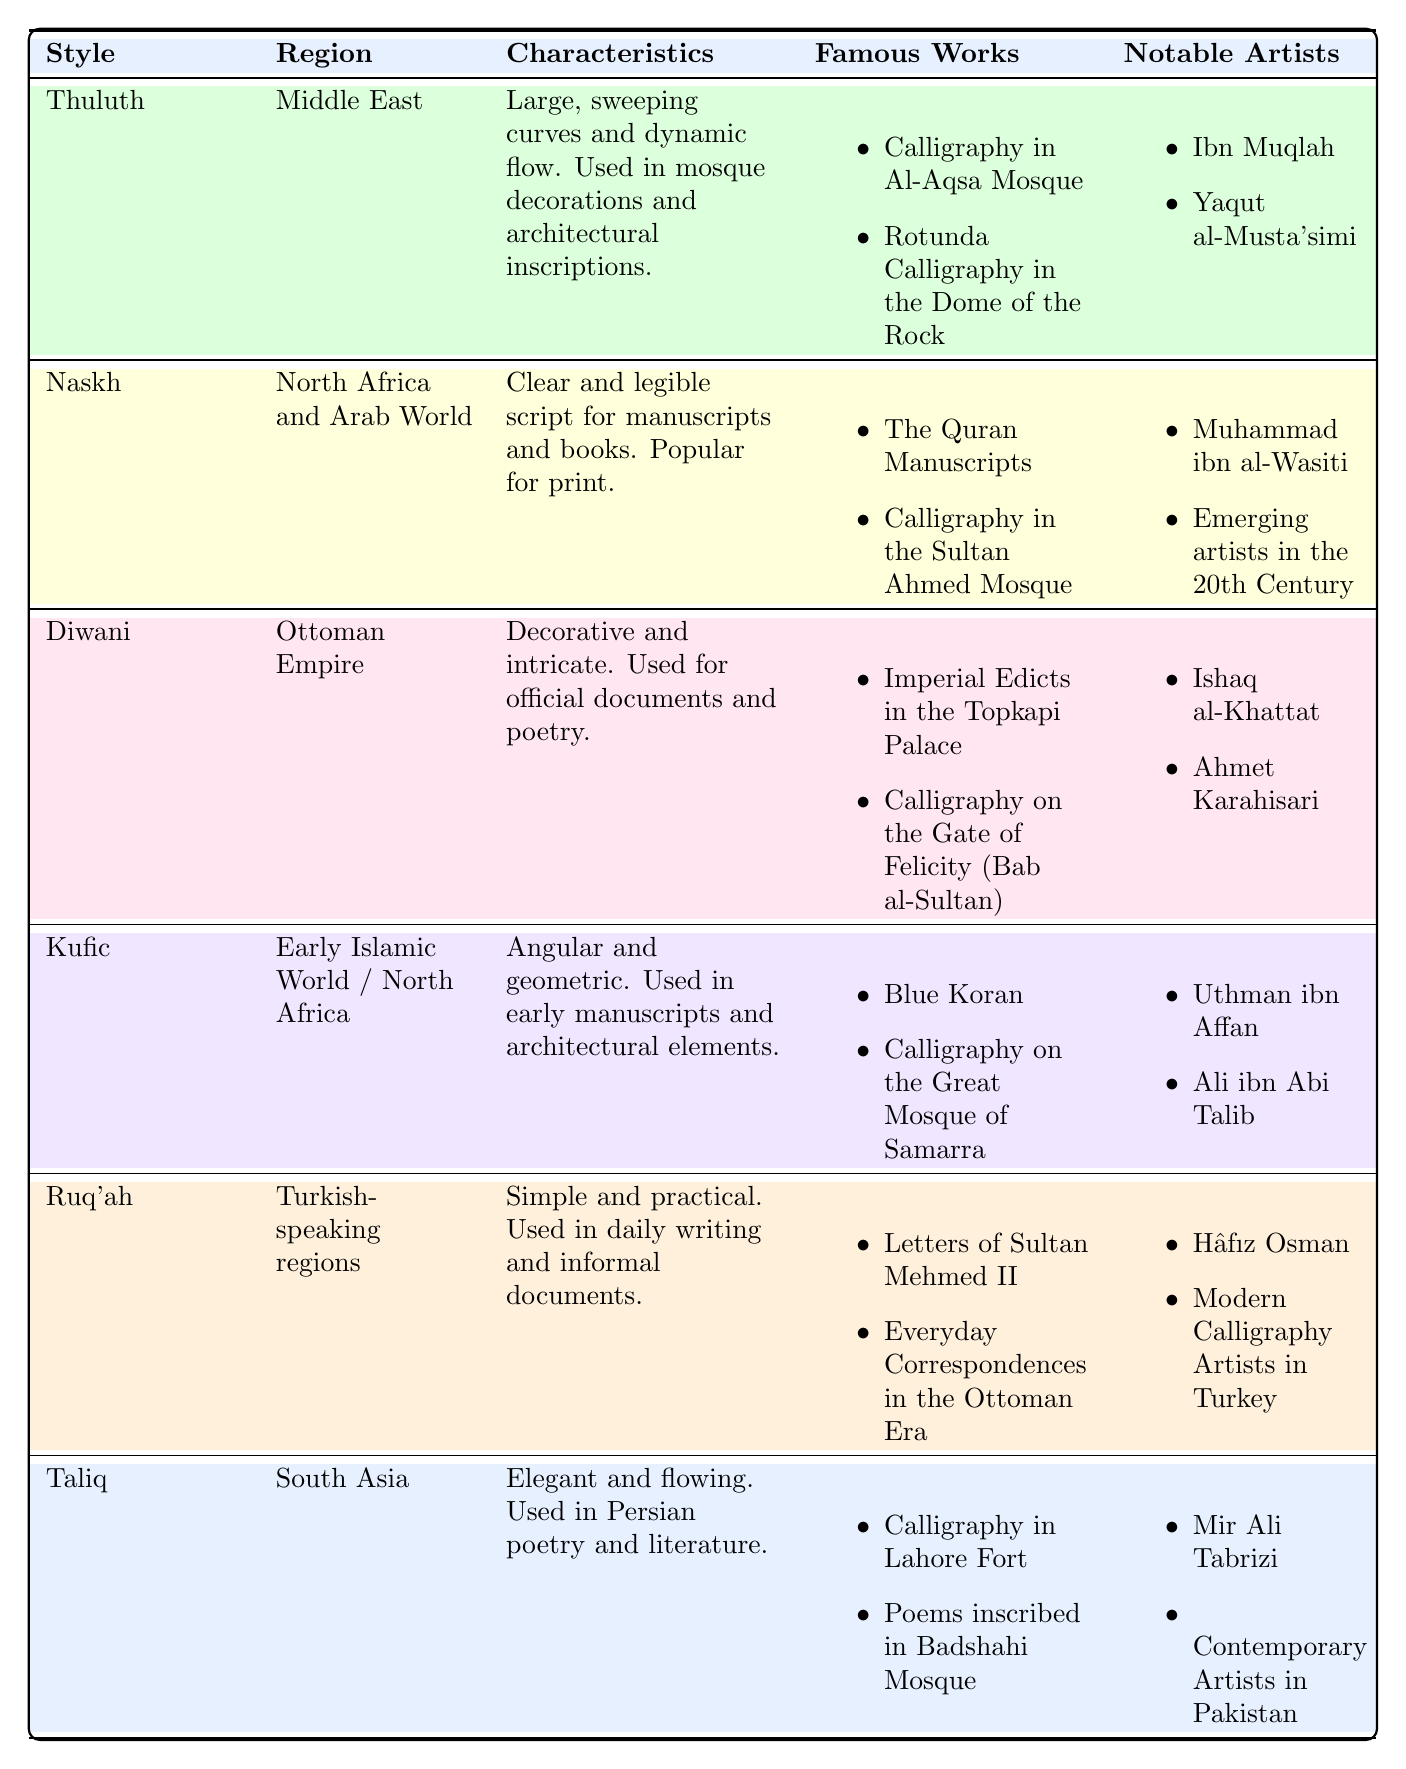What is the style of calligraphy known for its large, sweeping curves? The table lists the style of calligraphy known for its large, sweeping curves as "Thuluth."
Answer: Thuluth Which region is associated with the Naskh style of calligraphy? According to the table, the Naskh style is associated with "North Africa and Arab World."
Answer: North Africa and Arab World Is the Kufic style characterized by angular and geometric forms? The table clearly states that the Kufic style is defined by its angular and geometric characteristics, thus the answer is yes.
Answer: Yes What are two famous works associated with the Diwani style? In the table, the famous works listed under the Diwani style include "Imperial Edicts in the Topkapi Palace" and "Calligraphy on the Gate of Felicity (Bab al-Sultan)."
Answer: Imperial Edicts in the Topkapi Palace, Calligraphy on the Gate of Felicity (Bab al-Sultan) Which style of calligraphy is used for Persian poetry and literature, and what is its region? The table indicates that the Taliq style is used for Persian poetry and literature, and it is associated with the "South Asia" region.
Answer: Taliq; South Asia How many notable artists are mentioned for the Ruq'ah style? According to the table, there are two notable artists listed for the Ruq'ah style: "Hâfız Osman" and "Modern Calligraphy Artists in Turkey."
Answer: 2 What is the primary characteristic of the calligraphy style used in mosque decorations from the Middle East? The table specifies that the Thuluth style, which is used in mosque decorations from the Middle East, is characterized by large, sweeping curves and a dynamic flow.
Answer: Large, sweeping curves and dynamic flow Which styles are associated with the Ottoman Empire? The table indicates that the Diwani style is associated with the Ottoman Empire, and no other styles are listed for this region.
Answer: Diwani Explain the difference between the characteristics of Naskh and Ruq'ah styles. The Naskh style is described as clear and legible, often used for manuscripts and books, while the Ruq'ah style is characterized as simple and practical, used in everyday writing and informal documents. This indicates that Naskh is more formal and structured, while Ruq'ah is more casual and practical.
Answer: Naskh is clear and legible; Ruq'ah is simple and practical 